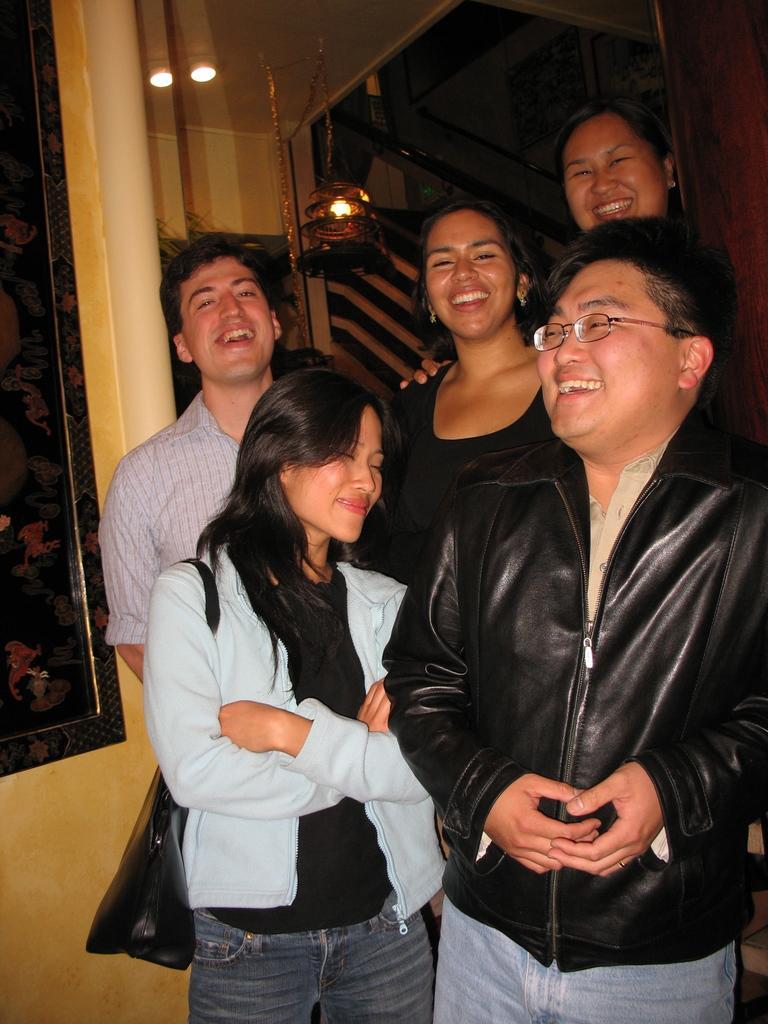Please provide a concise description of this image. There is a group of five members standing here. All of them were smiling. Three of them were women and two of them were men. One of the guy is wearing spectacles. In the background, there is a light and wall here. 